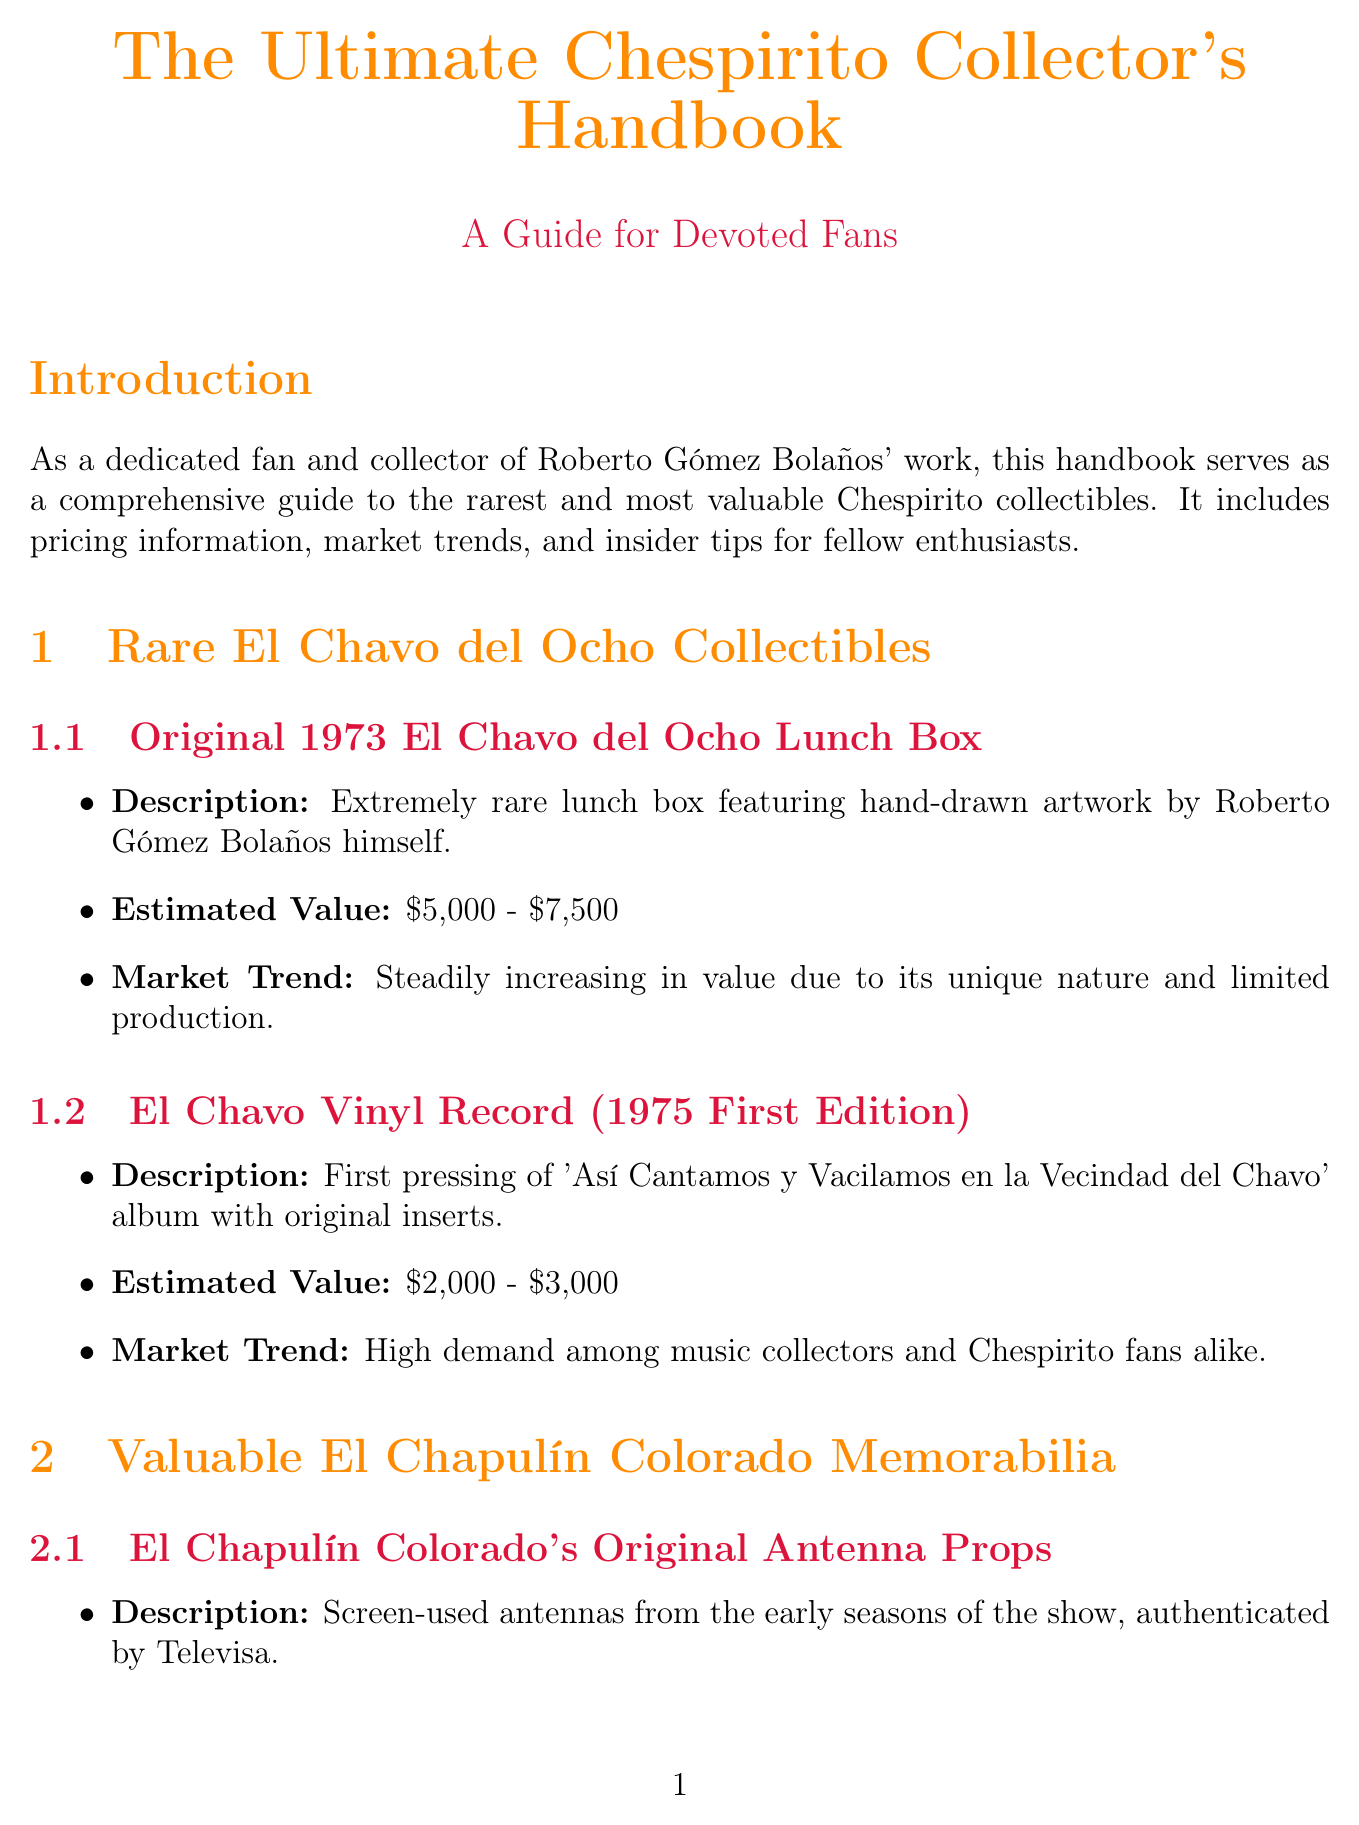What is the title of the handbook? The title of the handbook is provided in the document's title section.
Answer: The Ultimate Chespirito Collector's Handbook What is the estimated value range of the Original 1973 El Chavo del Ocho Lunch Box? The estimated value is listed in the section on rare El Chavo del Ocho collectibles.
Answer: $5,000 - $7,500 What type of collectible is El Chapulín Colorado's Original Antenna Props? The type of collectible is mentioned in the valuable El Chapulín Colorado memorabilia section.
Answer: Antenna Props What year was the El Chavo Vinyl Record first edition released? The year of release is found in the description of the vinyl record.
Answer: 1975 Which Chespirito collectible has the highest estimated value? This can be determined by comparing the estimated values of the collectibles listed in the document.
Answer: Chespirito's Personal Sketchbook When was the 1974 El Chapulín Colorado Board Game produced? The production year is specified in the description of the board game.
Answer: 1974 What is emphasized as important for maintaining the value of collectibles? Insights about maintaining value are found in the tips section of the document.
Answer: Authentication What is the market trend for the Original El Chavo del Ocho Script? The market trend is discussed in relation to its rarity and expected value increase.
Answer: Expected to increase significantly over time 